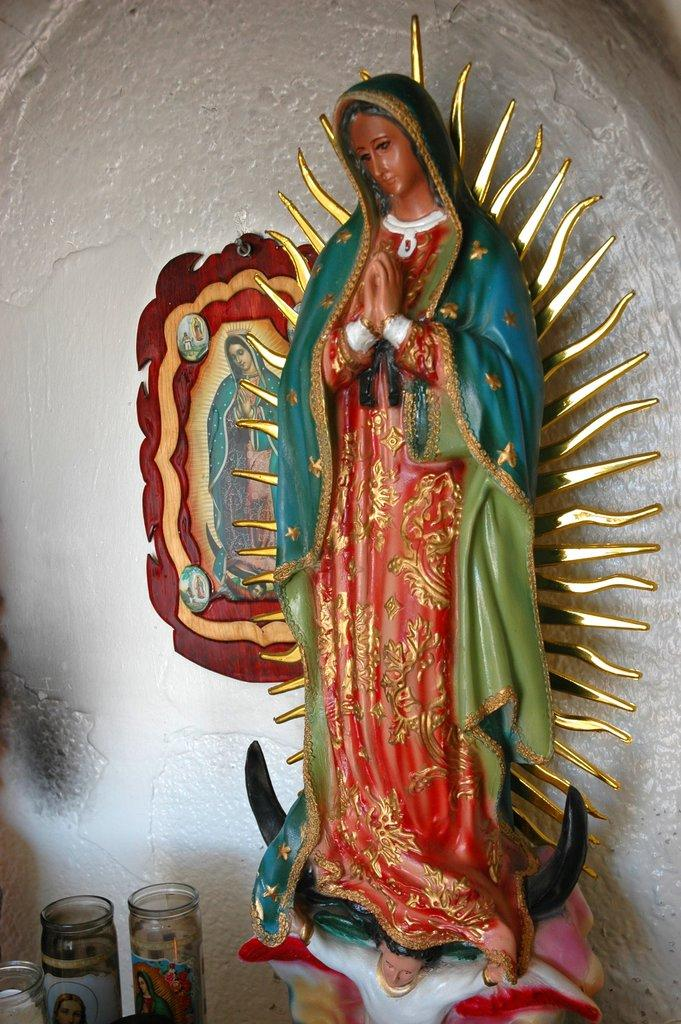What is the main subject of the image? There is a sculpture in the image. What other objects can be seen in the image? There are glass jars in the image. Is there any indication of a wall in the image? Yes, there is a frame attached to the wall in the image. How many goldfish are swimming in the sculpture in the image? There are no goldfish present in the image; the sculpture is not a body of water containing fish. 